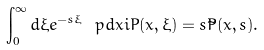Convert formula to latex. <formula><loc_0><loc_0><loc_500><loc_500>\int _ { 0 } ^ { \infty } d \xi e ^ { - s \xi } \ p d x i P ( x , \xi ) = s { \tilde { P } } ( x , s ) .</formula> 